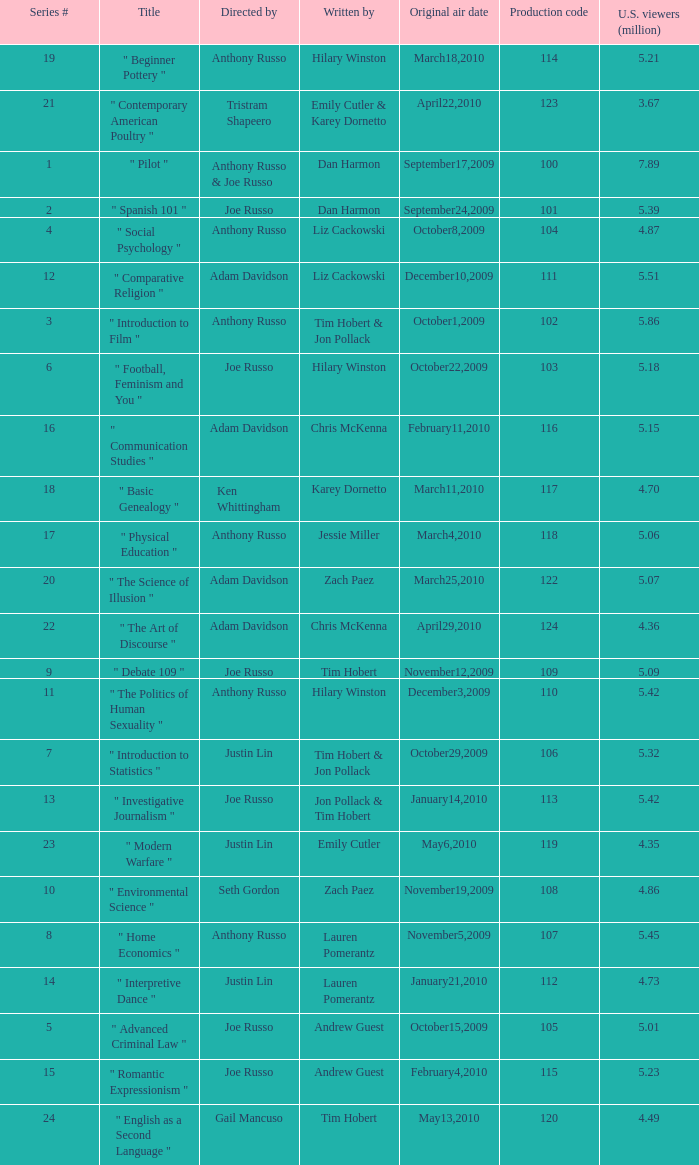What is the highest series # directed by ken whittingham? 18.0. 